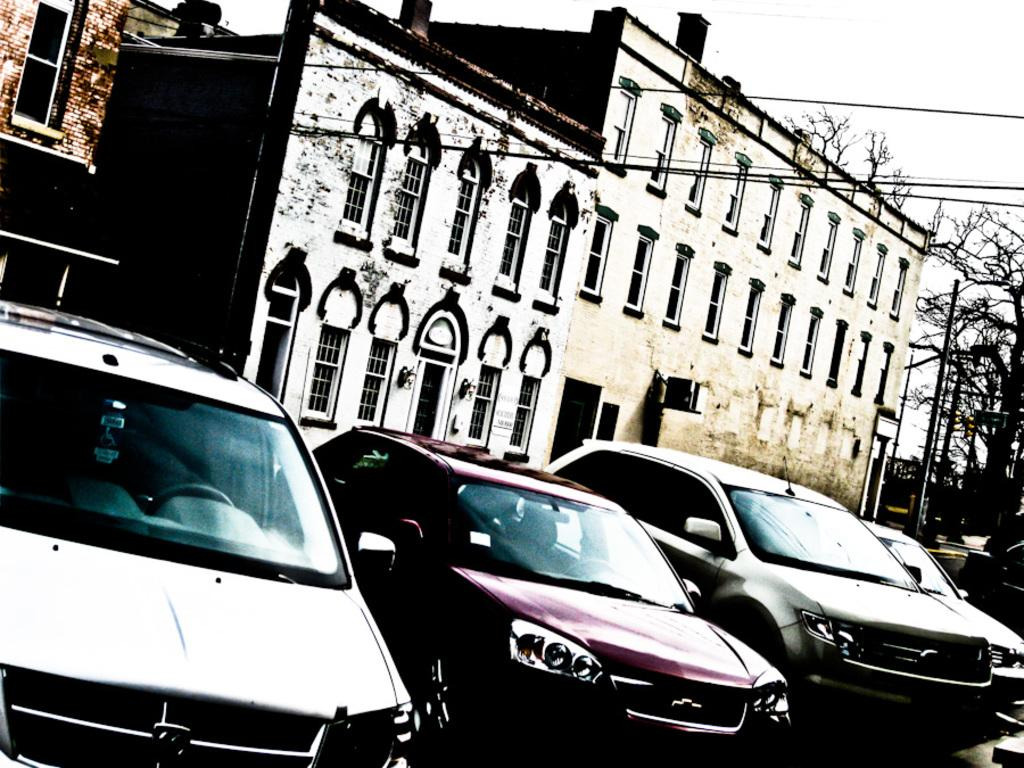What type of structures can be seen in the image? There are buildings in the image. What else is present in the image besides buildings? Cables, street poles, motor vehicles, trees, and the sky are visible in the image. Can you describe the road in the image? Motor vehicles are on the road in the image. What type of vegetation is present in the image? Trees are present in the image. Can you tell me how many kitties are sitting on the street poles in the image? There are no kitties present in the image; it only features buildings, cables, street poles, motor vehicles, trees, and the sky. Who is the writer of the book visible on the street pole in the image? There is no book visible on the street pole in the image. 